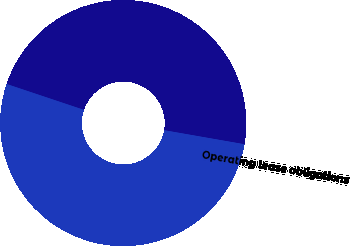Convert chart. <chart><loc_0><loc_0><loc_500><loc_500><pie_chart><fcel>Operating lease obligations<fcel>2125 junior convertible<fcel>Total contractual obligations<nl><fcel>0.01%<fcel>47.61%<fcel>52.37%<nl></chart> 